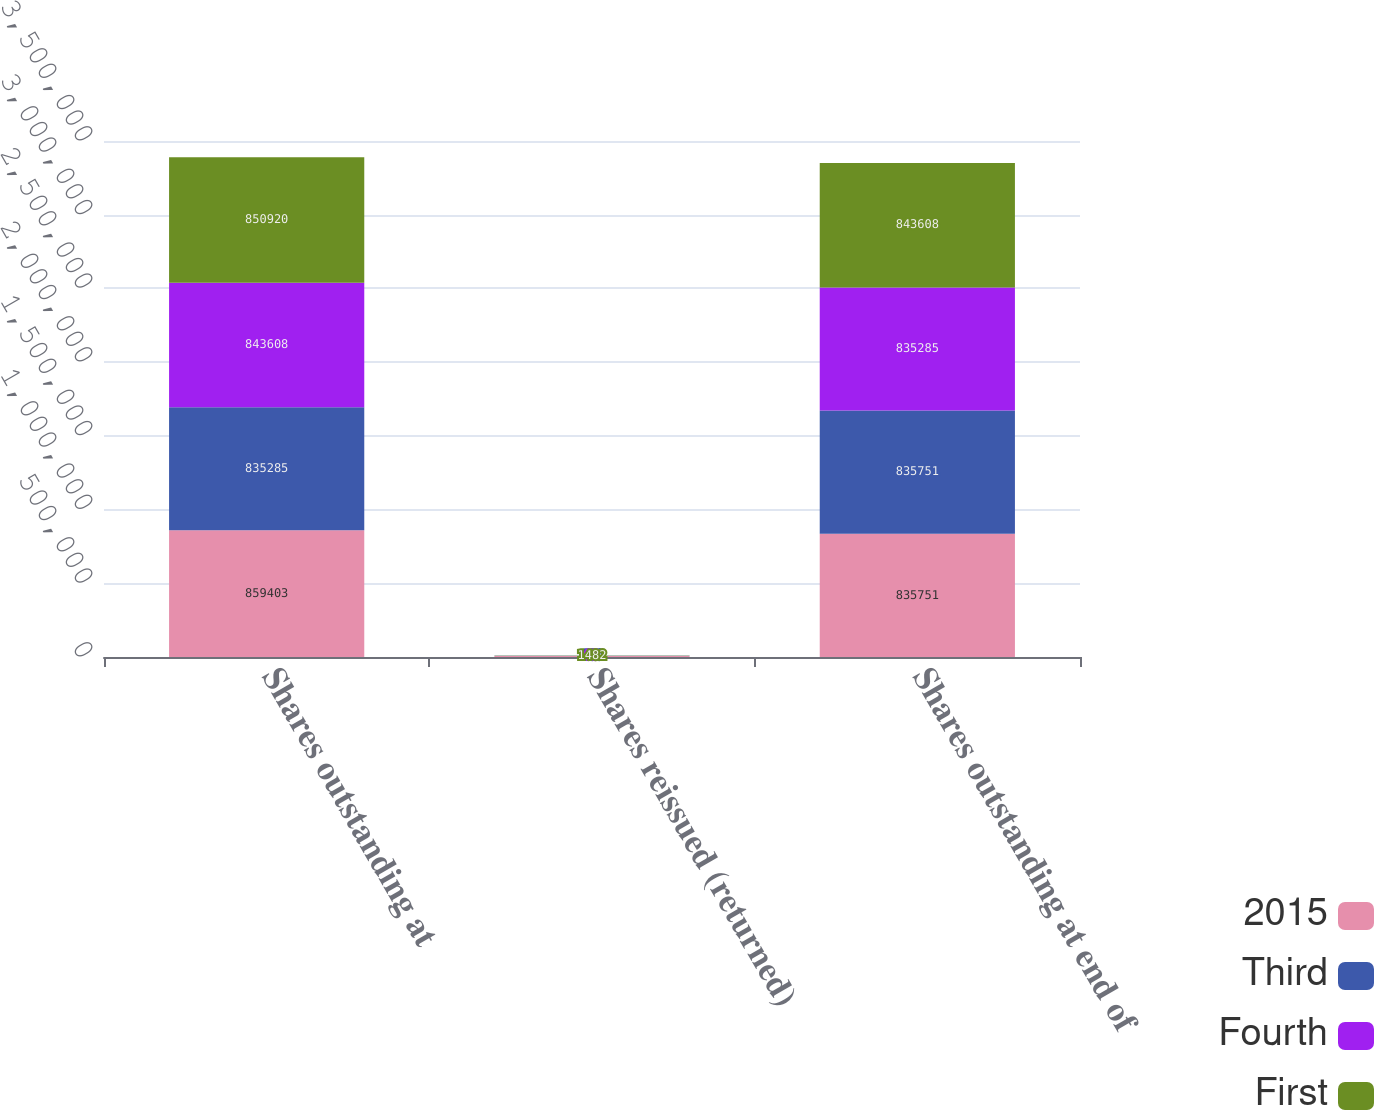<chart> <loc_0><loc_0><loc_500><loc_500><stacked_bar_chart><ecel><fcel>Shares outstanding at<fcel>Shares reissued (returned)<fcel>Shares outstanding at end of<nl><fcel>2015<fcel>859403<fcel>7582<fcel>835751<nl><fcel>Third<fcel>835285<fcel>466<fcel>835751<nl><fcel>Fourth<fcel>843608<fcel>63<fcel>835285<nl><fcel>First<fcel>850920<fcel>1482<fcel>843608<nl></chart> 